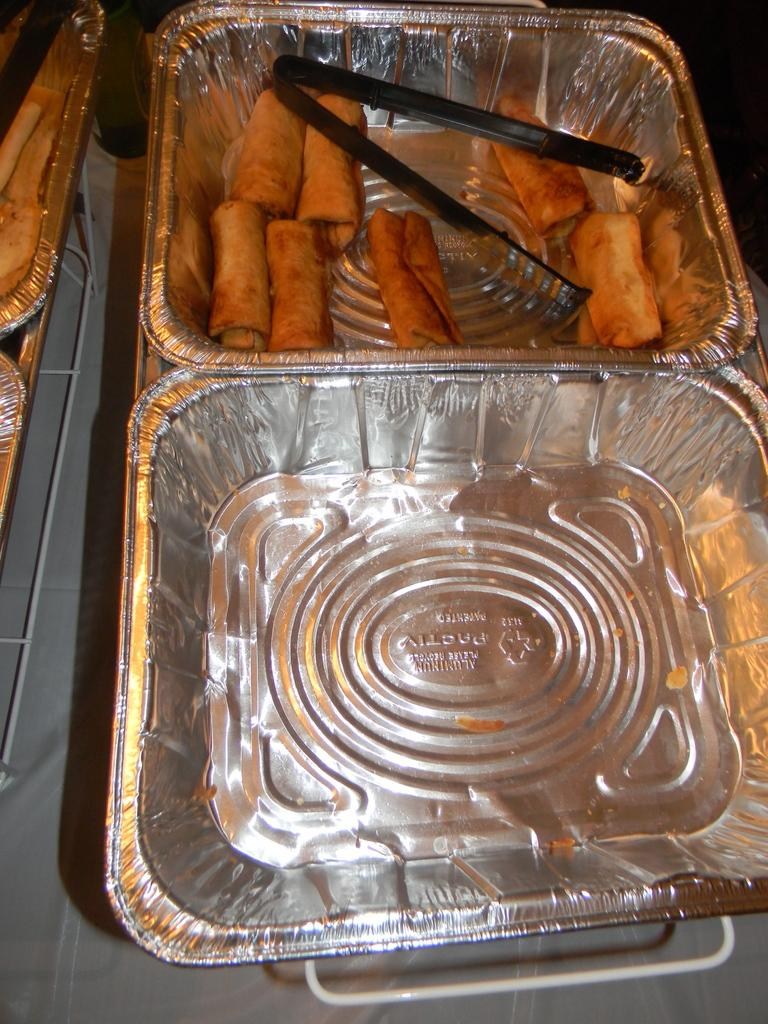What is present in the image related to food? There is food in the image. How is the food arranged or contained in the image? The food is in a plate. What utensil or tool is visible in the image? There is a tong in the image. How many pizzas are being driven by the car in the image? There are no pizzas or cars present in the image. How many kittens are sitting on the plate with the food in the image? There are no kittens present in the image; the food is on a plate. 